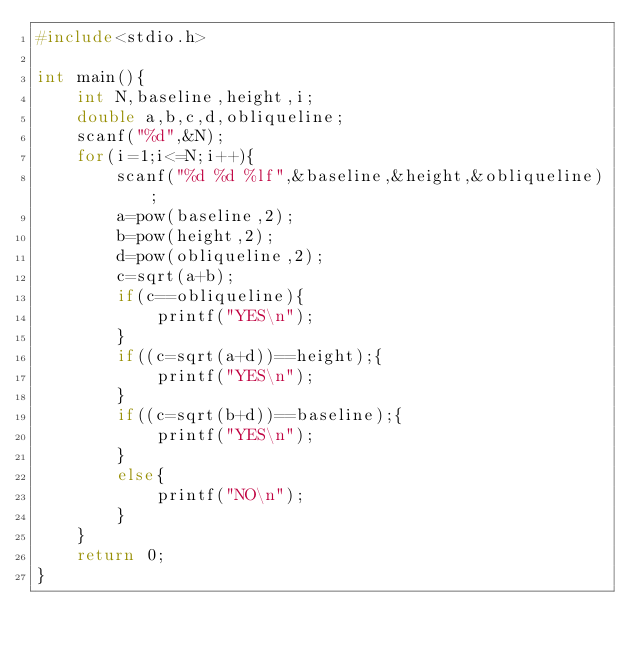Convert code to text. <code><loc_0><loc_0><loc_500><loc_500><_C_>#include<stdio.h>

int main(){
	int N,baseline,height,i;
	double a,b,c,d,obliqueline;
	scanf("%d",&N);
	for(i=1;i<=N;i++){
		scanf("%d %d %lf",&baseline,&height,&obliqueline);
		a=pow(baseline,2);
		b=pow(height,2);
		d=pow(obliqueline,2);
		c=sqrt(a+b);
		if(c==obliqueline){
			printf("YES\n");
		}
		if((c=sqrt(a+d))==height);{
			printf("YES\n");
		}
		if((c=sqrt(b+d))==baseline);{
			printf("YES\n");
		}
		else{
			printf("NO\n");
		}
	}
	return 0;
}</code> 